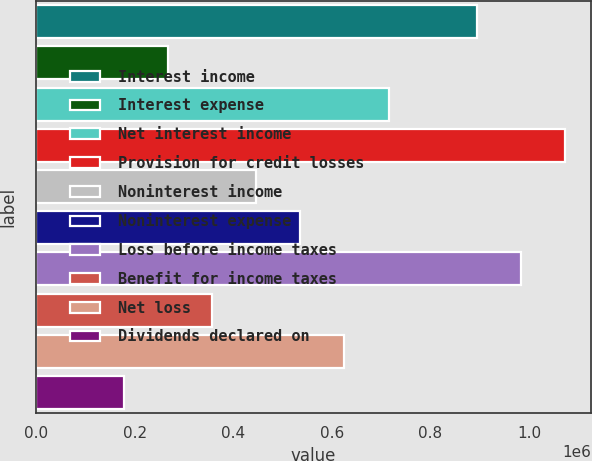Convert chart to OTSL. <chart><loc_0><loc_0><loc_500><loc_500><bar_chart><fcel>Interest income<fcel>Interest expense<fcel>Net interest income<fcel>Provision for credit losses<fcel>Noninterest income<fcel>Noninterest expense<fcel>Loss before income taxes<fcel>Benefit for income taxes<fcel>Net loss<fcel>Dividends declared on<nl><fcel>893991<fcel>268198<fcel>715193<fcel>1.07279e+06<fcel>446996<fcel>536395<fcel>983390<fcel>357597<fcel>625794<fcel>178799<nl></chart> 